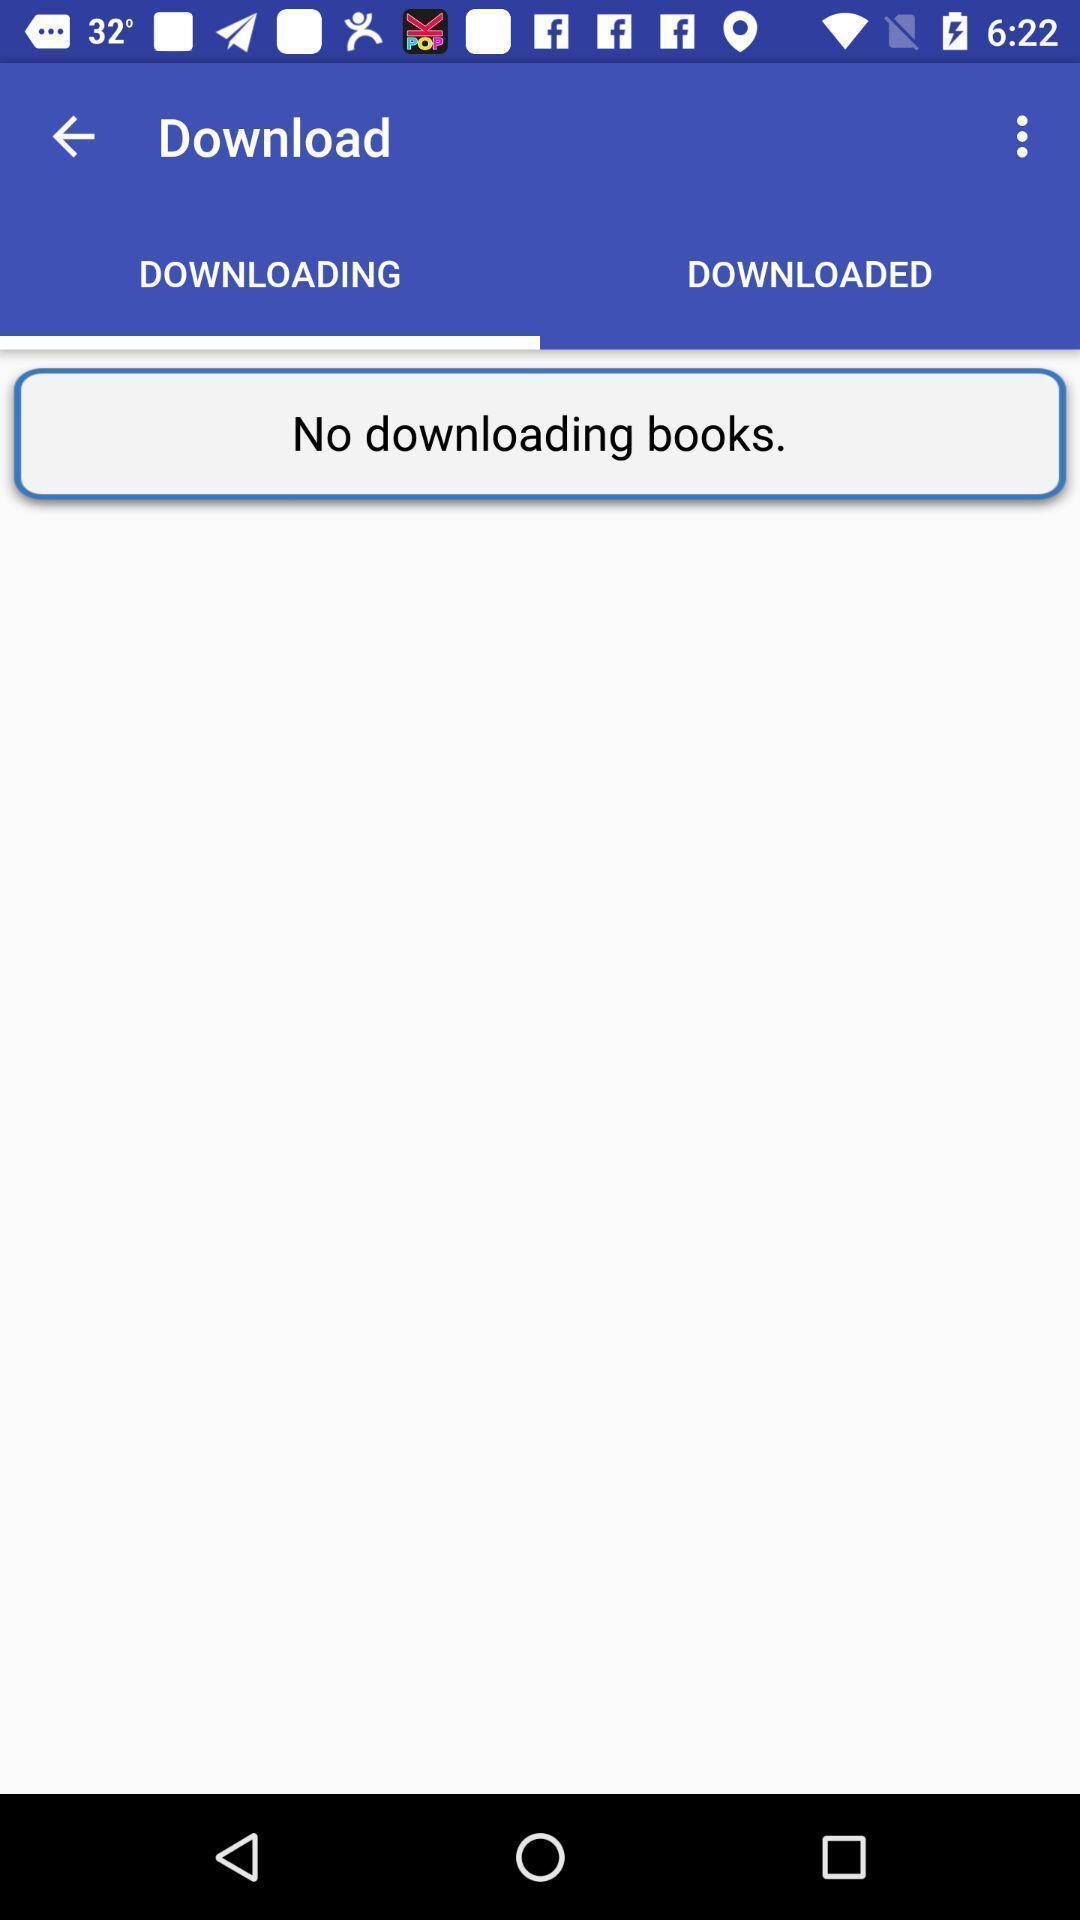Describe the content in this image. Page displaying results for downloads. 